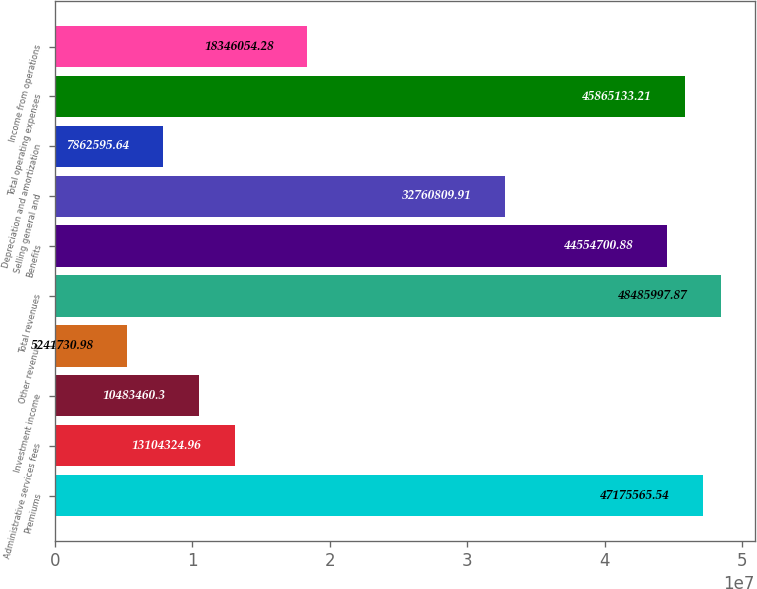<chart> <loc_0><loc_0><loc_500><loc_500><bar_chart><fcel>Premiums<fcel>Administrative services fees<fcel>Investment income<fcel>Other revenue<fcel>Total revenues<fcel>Benefits<fcel>Selling general and<fcel>Depreciation and amortization<fcel>Total operating expenses<fcel>Income from operations<nl><fcel>4.71756e+07<fcel>1.31043e+07<fcel>1.04835e+07<fcel>5.24173e+06<fcel>4.8486e+07<fcel>4.45547e+07<fcel>3.27608e+07<fcel>7.8626e+06<fcel>4.58651e+07<fcel>1.83461e+07<nl></chart> 